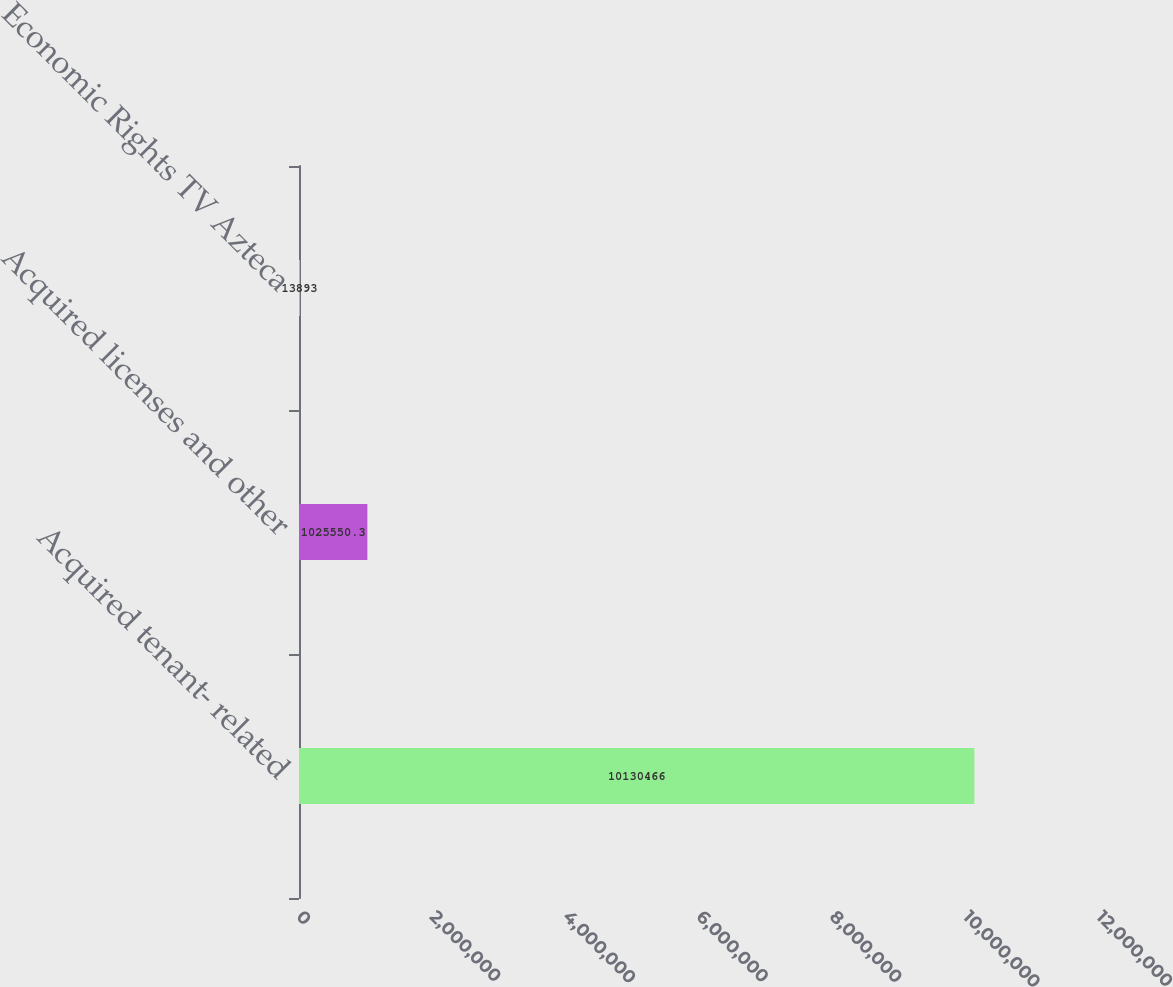<chart> <loc_0><loc_0><loc_500><loc_500><bar_chart><fcel>Acquired tenant- related<fcel>Acquired licenses and other<fcel>Economic Rights TV Azteca<nl><fcel>1.01305e+07<fcel>1.02555e+06<fcel>13893<nl></chart> 